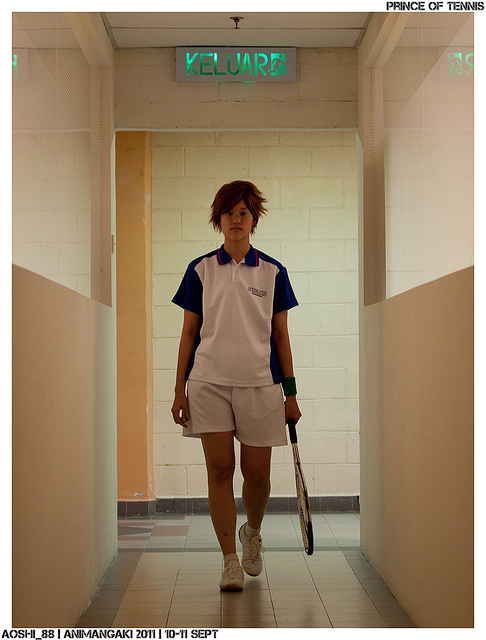Please extract the text content from this image. KELUAR AOSHI_88 ANIMANGAKI 2011 10-11 SEPT R TENNIS OF PRINCE 